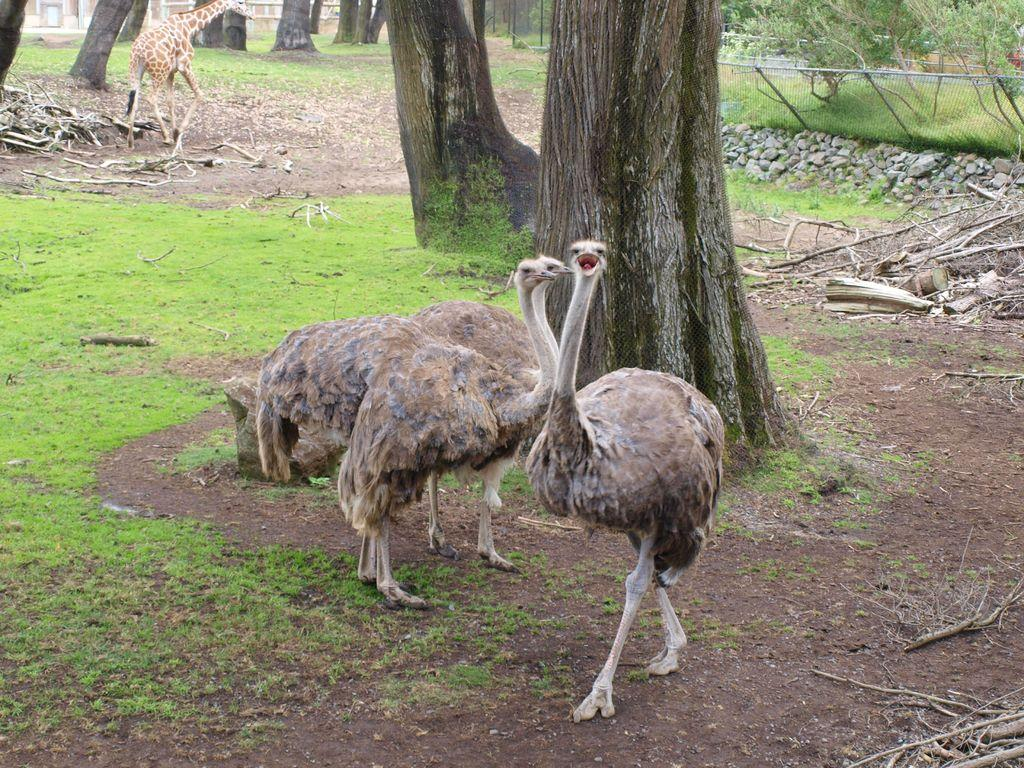What animals are in the center of the image? There are three ostriches in the center of the image? What can be seen in the background of the image? In the background of the image, there are trees, grass, stones, fences, and a giraffe. How many ostriches are in the image? There are three ostriches in the image. What type of vegetation is present in the background of the image? There are trees and grass in the background of the image. What type of structure is visible in the background of the image? There are fences in the background of the image. Can you describe the giraffe in the image? There is a giraffe in the background of the image. How many rabbits can be seen in the image? There are no rabbits present in the image. 